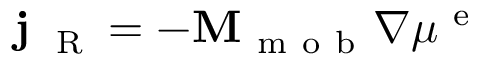Convert formula to latex. <formula><loc_0><loc_0><loc_500><loc_500>{ j } _ { R } = - { M } _ { m o b } \nabla \mu ^ { e }</formula> 